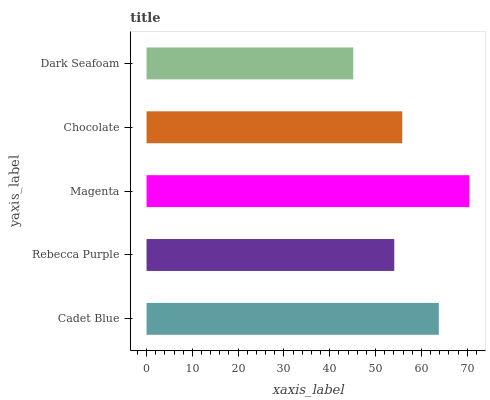Is Dark Seafoam the minimum?
Answer yes or no. Yes. Is Magenta the maximum?
Answer yes or no. Yes. Is Rebecca Purple the minimum?
Answer yes or no. No. Is Rebecca Purple the maximum?
Answer yes or no. No. Is Cadet Blue greater than Rebecca Purple?
Answer yes or no. Yes. Is Rebecca Purple less than Cadet Blue?
Answer yes or no. Yes. Is Rebecca Purple greater than Cadet Blue?
Answer yes or no. No. Is Cadet Blue less than Rebecca Purple?
Answer yes or no. No. Is Chocolate the high median?
Answer yes or no. Yes. Is Chocolate the low median?
Answer yes or no. Yes. Is Magenta the high median?
Answer yes or no. No. Is Cadet Blue the low median?
Answer yes or no. No. 